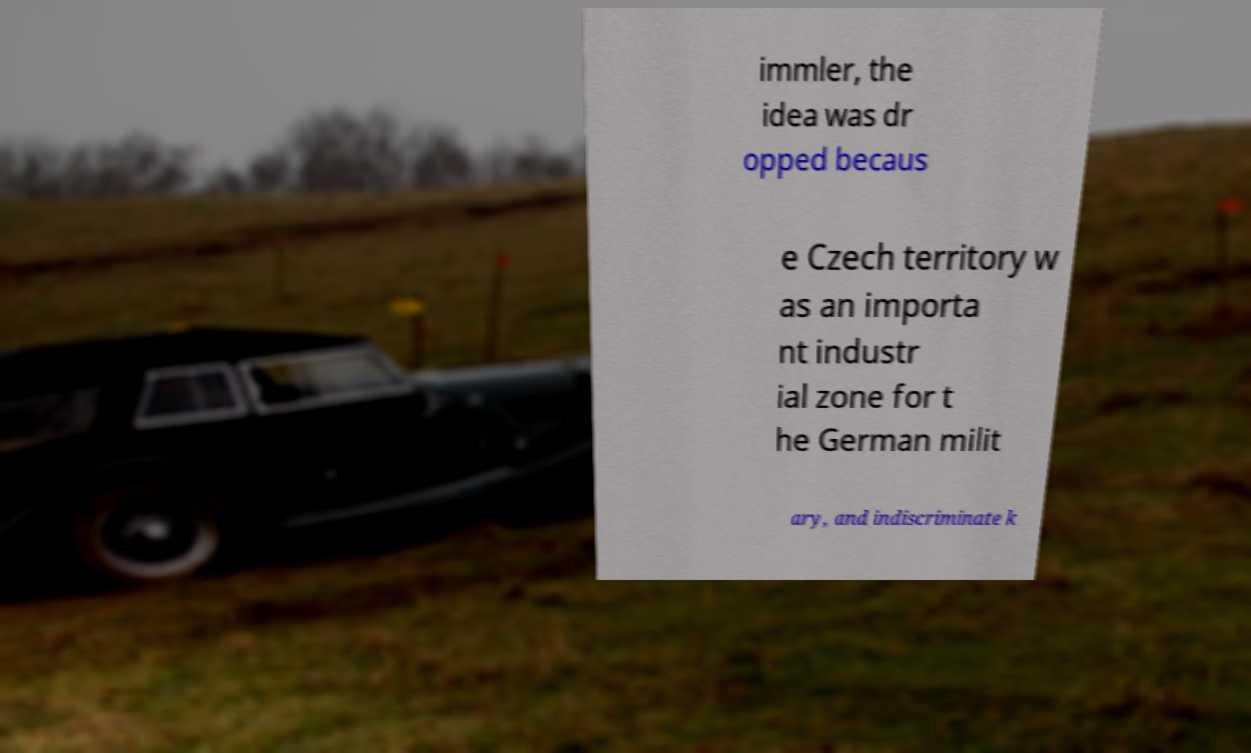There's text embedded in this image that I need extracted. Can you transcribe it verbatim? immler, the idea was dr opped becaus e Czech territory w as an importa nt industr ial zone for t he German milit ary, and indiscriminate k 